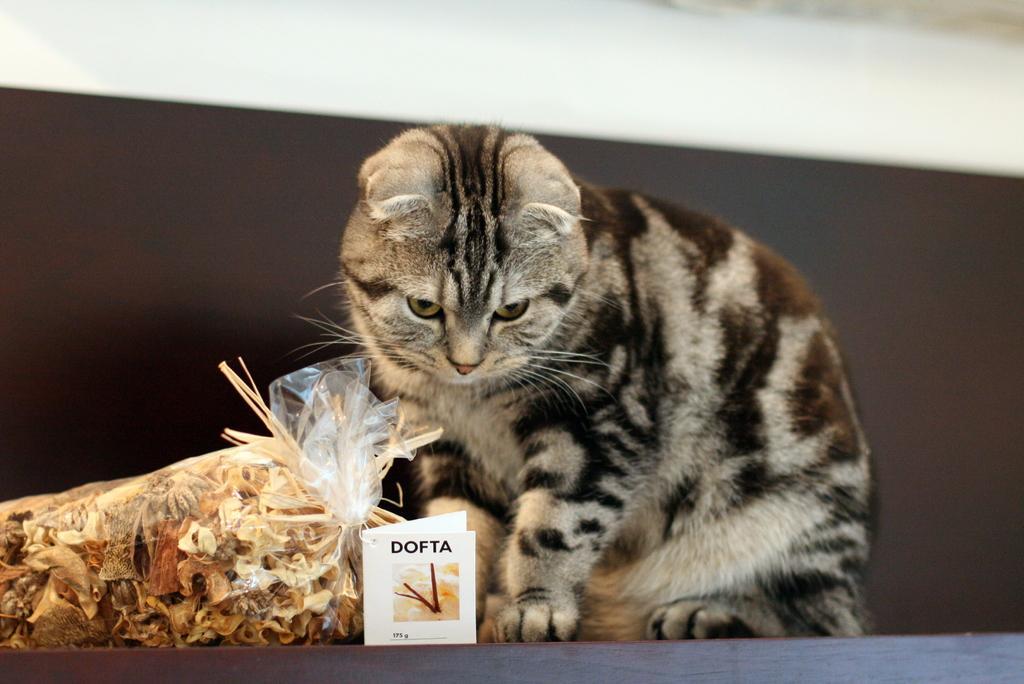In one or two sentences, can you explain what this image depicts? This image consists of a cat. There is some cover on the left side. There is some paper at the bottom. 